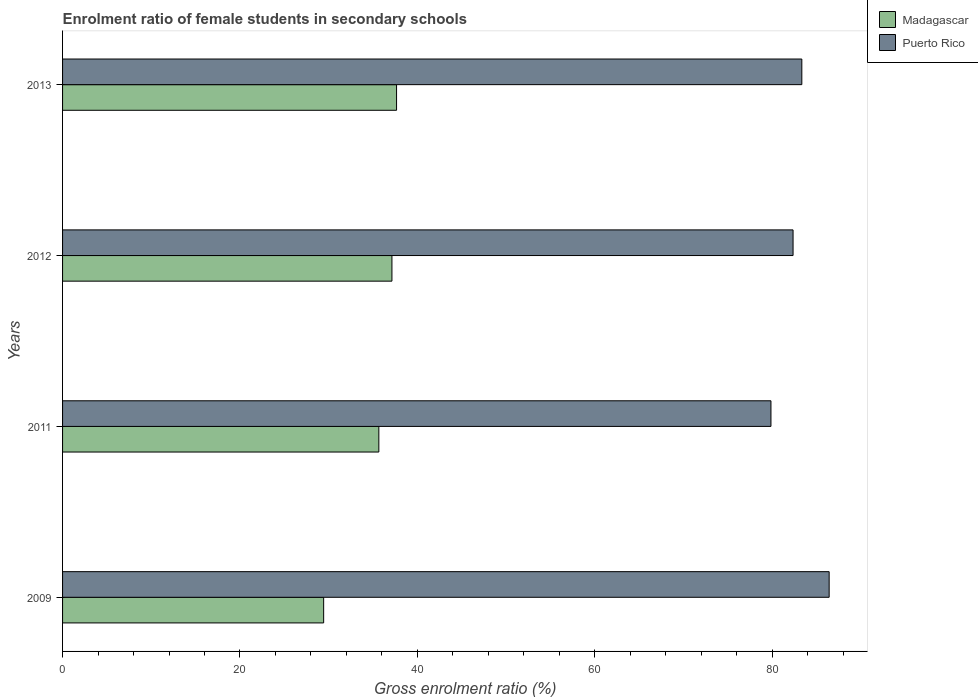How many groups of bars are there?
Ensure brevity in your answer.  4. Are the number of bars per tick equal to the number of legend labels?
Offer a terse response. Yes. Are the number of bars on each tick of the Y-axis equal?
Offer a terse response. Yes. How many bars are there on the 4th tick from the top?
Make the answer very short. 2. How many bars are there on the 2nd tick from the bottom?
Offer a very short reply. 2. What is the enrolment ratio of female students in secondary schools in Madagascar in 2011?
Your answer should be compact. 35.65. Across all years, what is the maximum enrolment ratio of female students in secondary schools in Madagascar?
Give a very brief answer. 37.65. Across all years, what is the minimum enrolment ratio of female students in secondary schools in Madagascar?
Offer a very short reply. 29.43. In which year was the enrolment ratio of female students in secondary schools in Madagascar minimum?
Offer a very short reply. 2009. What is the total enrolment ratio of female students in secondary schools in Puerto Rico in the graph?
Your answer should be compact. 331.95. What is the difference between the enrolment ratio of female students in secondary schools in Madagascar in 2011 and that in 2012?
Provide a succinct answer. -1.48. What is the difference between the enrolment ratio of female students in secondary schools in Madagascar in 2013 and the enrolment ratio of female students in secondary schools in Puerto Rico in 2012?
Ensure brevity in your answer.  -44.7. What is the average enrolment ratio of female students in secondary schools in Madagascar per year?
Provide a short and direct response. 34.97. In the year 2009, what is the difference between the enrolment ratio of female students in secondary schools in Madagascar and enrolment ratio of female students in secondary schools in Puerto Rico?
Offer a very short reply. -56.98. In how many years, is the enrolment ratio of female students in secondary schools in Madagascar greater than 64 %?
Give a very brief answer. 0. What is the ratio of the enrolment ratio of female students in secondary schools in Puerto Rico in 2009 to that in 2011?
Your answer should be compact. 1.08. Is the difference between the enrolment ratio of female students in secondary schools in Madagascar in 2012 and 2013 greater than the difference between the enrolment ratio of female students in secondary schools in Puerto Rico in 2012 and 2013?
Your answer should be compact. Yes. What is the difference between the highest and the second highest enrolment ratio of female students in secondary schools in Puerto Rico?
Provide a short and direct response. 3.08. What is the difference between the highest and the lowest enrolment ratio of female students in secondary schools in Puerto Rico?
Your response must be concise. 6.56. Is the sum of the enrolment ratio of female students in secondary schools in Madagascar in 2009 and 2013 greater than the maximum enrolment ratio of female students in secondary schools in Puerto Rico across all years?
Keep it short and to the point. No. What does the 1st bar from the top in 2009 represents?
Make the answer very short. Puerto Rico. What does the 2nd bar from the bottom in 2011 represents?
Give a very brief answer. Puerto Rico. Are all the bars in the graph horizontal?
Your answer should be compact. Yes. How many years are there in the graph?
Keep it short and to the point. 4. Does the graph contain any zero values?
Your response must be concise. No. Does the graph contain grids?
Your answer should be very brief. No. Where does the legend appear in the graph?
Ensure brevity in your answer.  Top right. How are the legend labels stacked?
Offer a terse response. Vertical. What is the title of the graph?
Your answer should be compact. Enrolment ratio of female students in secondary schools. Does "Iran" appear as one of the legend labels in the graph?
Your answer should be compact. No. What is the label or title of the X-axis?
Give a very brief answer. Gross enrolment ratio (%). What is the label or title of the Y-axis?
Your response must be concise. Years. What is the Gross enrolment ratio (%) of Madagascar in 2009?
Provide a short and direct response. 29.43. What is the Gross enrolment ratio (%) of Puerto Rico in 2009?
Provide a short and direct response. 86.42. What is the Gross enrolment ratio (%) of Madagascar in 2011?
Your answer should be compact. 35.65. What is the Gross enrolment ratio (%) in Puerto Rico in 2011?
Give a very brief answer. 79.85. What is the Gross enrolment ratio (%) in Madagascar in 2012?
Keep it short and to the point. 37.13. What is the Gross enrolment ratio (%) in Puerto Rico in 2012?
Keep it short and to the point. 82.35. What is the Gross enrolment ratio (%) of Madagascar in 2013?
Keep it short and to the point. 37.65. What is the Gross enrolment ratio (%) of Puerto Rico in 2013?
Your answer should be very brief. 83.33. Across all years, what is the maximum Gross enrolment ratio (%) of Madagascar?
Offer a terse response. 37.65. Across all years, what is the maximum Gross enrolment ratio (%) in Puerto Rico?
Give a very brief answer. 86.42. Across all years, what is the minimum Gross enrolment ratio (%) in Madagascar?
Provide a short and direct response. 29.43. Across all years, what is the minimum Gross enrolment ratio (%) in Puerto Rico?
Ensure brevity in your answer.  79.85. What is the total Gross enrolment ratio (%) in Madagascar in the graph?
Your response must be concise. 139.86. What is the total Gross enrolment ratio (%) of Puerto Rico in the graph?
Provide a short and direct response. 331.95. What is the difference between the Gross enrolment ratio (%) in Madagascar in 2009 and that in 2011?
Your answer should be very brief. -6.22. What is the difference between the Gross enrolment ratio (%) in Puerto Rico in 2009 and that in 2011?
Make the answer very short. 6.56. What is the difference between the Gross enrolment ratio (%) of Madagascar in 2009 and that in 2012?
Provide a succinct answer. -7.7. What is the difference between the Gross enrolment ratio (%) in Puerto Rico in 2009 and that in 2012?
Provide a short and direct response. 4.07. What is the difference between the Gross enrolment ratio (%) of Madagascar in 2009 and that in 2013?
Provide a short and direct response. -8.22. What is the difference between the Gross enrolment ratio (%) in Puerto Rico in 2009 and that in 2013?
Provide a short and direct response. 3.08. What is the difference between the Gross enrolment ratio (%) of Madagascar in 2011 and that in 2012?
Your response must be concise. -1.48. What is the difference between the Gross enrolment ratio (%) of Puerto Rico in 2011 and that in 2012?
Provide a succinct answer. -2.49. What is the difference between the Gross enrolment ratio (%) in Madagascar in 2011 and that in 2013?
Offer a terse response. -2. What is the difference between the Gross enrolment ratio (%) in Puerto Rico in 2011 and that in 2013?
Keep it short and to the point. -3.48. What is the difference between the Gross enrolment ratio (%) in Madagascar in 2012 and that in 2013?
Give a very brief answer. -0.52. What is the difference between the Gross enrolment ratio (%) of Puerto Rico in 2012 and that in 2013?
Ensure brevity in your answer.  -0.99. What is the difference between the Gross enrolment ratio (%) of Madagascar in 2009 and the Gross enrolment ratio (%) of Puerto Rico in 2011?
Your answer should be compact. -50.42. What is the difference between the Gross enrolment ratio (%) in Madagascar in 2009 and the Gross enrolment ratio (%) in Puerto Rico in 2012?
Keep it short and to the point. -52.91. What is the difference between the Gross enrolment ratio (%) of Madagascar in 2009 and the Gross enrolment ratio (%) of Puerto Rico in 2013?
Ensure brevity in your answer.  -53.9. What is the difference between the Gross enrolment ratio (%) in Madagascar in 2011 and the Gross enrolment ratio (%) in Puerto Rico in 2012?
Keep it short and to the point. -46.69. What is the difference between the Gross enrolment ratio (%) in Madagascar in 2011 and the Gross enrolment ratio (%) in Puerto Rico in 2013?
Your answer should be very brief. -47.68. What is the difference between the Gross enrolment ratio (%) of Madagascar in 2012 and the Gross enrolment ratio (%) of Puerto Rico in 2013?
Make the answer very short. -46.2. What is the average Gross enrolment ratio (%) in Madagascar per year?
Your answer should be compact. 34.97. What is the average Gross enrolment ratio (%) of Puerto Rico per year?
Give a very brief answer. 82.99. In the year 2009, what is the difference between the Gross enrolment ratio (%) of Madagascar and Gross enrolment ratio (%) of Puerto Rico?
Ensure brevity in your answer.  -56.98. In the year 2011, what is the difference between the Gross enrolment ratio (%) in Madagascar and Gross enrolment ratio (%) in Puerto Rico?
Give a very brief answer. -44.2. In the year 2012, what is the difference between the Gross enrolment ratio (%) in Madagascar and Gross enrolment ratio (%) in Puerto Rico?
Your answer should be compact. -45.22. In the year 2013, what is the difference between the Gross enrolment ratio (%) in Madagascar and Gross enrolment ratio (%) in Puerto Rico?
Offer a terse response. -45.68. What is the ratio of the Gross enrolment ratio (%) in Madagascar in 2009 to that in 2011?
Your answer should be very brief. 0.83. What is the ratio of the Gross enrolment ratio (%) in Puerto Rico in 2009 to that in 2011?
Ensure brevity in your answer.  1.08. What is the ratio of the Gross enrolment ratio (%) in Madagascar in 2009 to that in 2012?
Your answer should be compact. 0.79. What is the ratio of the Gross enrolment ratio (%) in Puerto Rico in 2009 to that in 2012?
Ensure brevity in your answer.  1.05. What is the ratio of the Gross enrolment ratio (%) in Madagascar in 2009 to that in 2013?
Provide a short and direct response. 0.78. What is the ratio of the Gross enrolment ratio (%) of Madagascar in 2011 to that in 2012?
Provide a short and direct response. 0.96. What is the ratio of the Gross enrolment ratio (%) in Puerto Rico in 2011 to that in 2012?
Make the answer very short. 0.97. What is the ratio of the Gross enrolment ratio (%) of Madagascar in 2011 to that in 2013?
Your answer should be compact. 0.95. What is the ratio of the Gross enrolment ratio (%) of Puerto Rico in 2011 to that in 2013?
Make the answer very short. 0.96. What is the ratio of the Gross enrolment ratio (%) in Madagascar in 2012 to that in 2013?
Ensure brevity in your answer.  0.99. What is the ratio of the Gross enrolment ratio (%) of Puerto Rico in 2012 to that in 2013?
Give a very brief answer. 0.99. What is the difference between the highest and the second highest Gross enrolment ratio (%) of Madagascar?
Ensure brevity in your answer.  0.52. What is the difference between the highest and the second highest Gross enrolment ratio (%) of Puerto Rico?
Provide a short and direct response. 3.08. What is the difference between the highest and the lowest Gross enrolment ratio (%) in Madagascar?
Give a very brief answer. 8.22. What is the difference between the highest and the lowest Gross enrolment ratio (%) in Puerto Rico?
Provide a short and direct response. 6.56. 